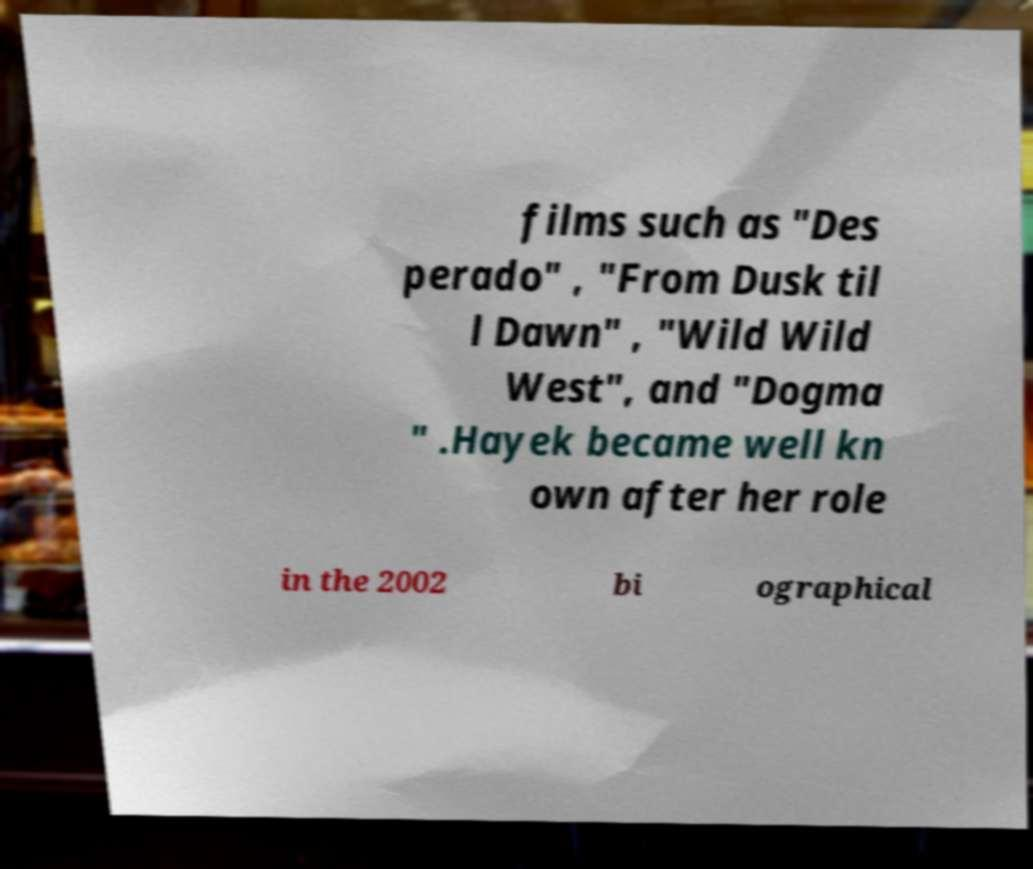For documentation purposes, I need the text within this image transcribed. Could you provide that? films such as "Des perado" , "From Dusk til l Dawn" , "Wild Wild West", and "Dogma " .Hayek became well kn own after her role in the 2002 bi ographical 